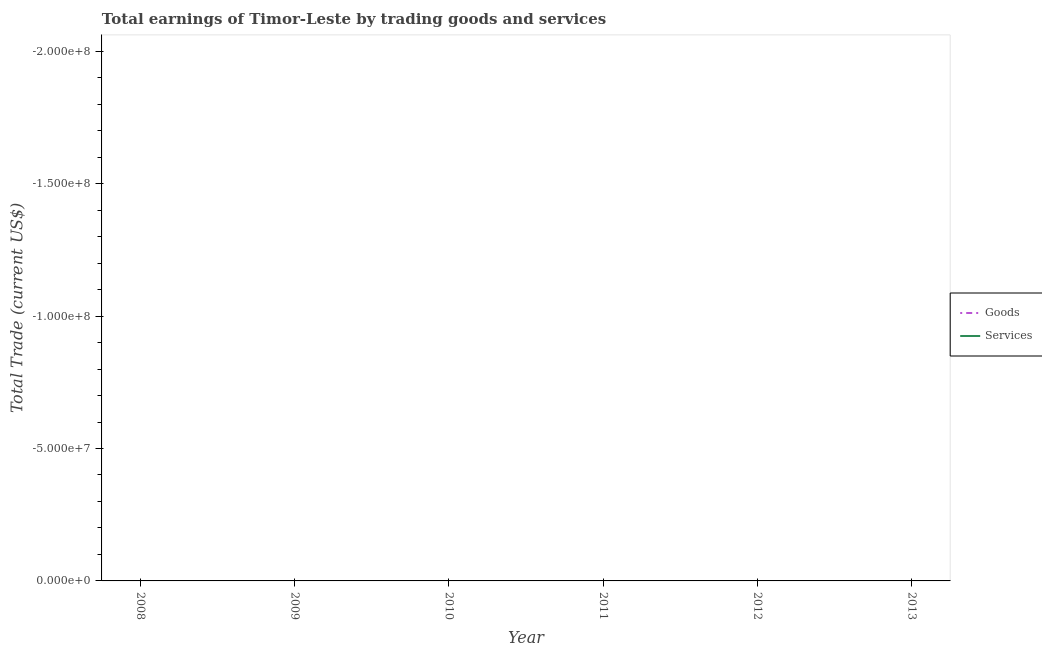Does the line corresponding to amount earned by trading services intersect with the line corresponding to amount earned by trading goods?
Provide a succinct answer. No. Across all years, what is the minimum amount earned by trading services?
Give a very brief answer. 0. What is the total amount earned by trading goods in the graph?
Offer a terse response. 0. What is the difference between the amount earned by trading goods in 2008 and the amount earned by trading services in 2010?
Your answer should be compact. 0. What is the average amount earned by trading goods per year?
Offer a very short reply. 0. In how many years, is the amount earned by trading services greater than -120000000 US$?
Give a very brief answer. 0. Does the amount earned by trading goods monotonically increase over the years?
Give a very brief answer. No. How many lines are there?
Your answer should be compact. 0. What is the difference between two consecutive major ticks on the Y-axis?
Ensure brevity in your answer.  5.00e+07. Does the graph contain grids?
Ensure brevity in your answer.  No. What is the title of the graph?
Ensure brevity in your answer.  Total earnings of Timor-Leste by trading goods and services. What is the label or title of the Y-axis?
Make the answer very short. Total Trade (current US$). What is the Total Trade (current US$) in Goods in 2008?
Keep it short and to the point. 0. What is the Total Trade (current US$) of Services in 2008?
Your answer should be compact. 0. What is the Total Trade (current US$) of Goods in 2010?
Your answer should be compact. 0. What is the Total Trade (current US$) of Goods in 2012?
Provide a short and direct response. 0. What is the Total Trade (current US$) in Services in 2012?
Your answer should be very brief. 0. What is the Total Trade (current US$) of Goods in 2013?
Keep it short and to the point. 0. What is the Total Trade (current US$) of Services in 2013?
Provide a succinct answer. 0. What is the total Total Trade (current US$) in Goods in the graph?
Give a very brief answer. 0. What is the total Total Trade (current US$) of Services in the graph?
Provide a succinct answer. 0. What is the average Total Trade (current US$) of Goods per year?
Your response must be concise. 0. What is the average Total Trade (current US$) in Services per year?
Make the answer very short. 0. 